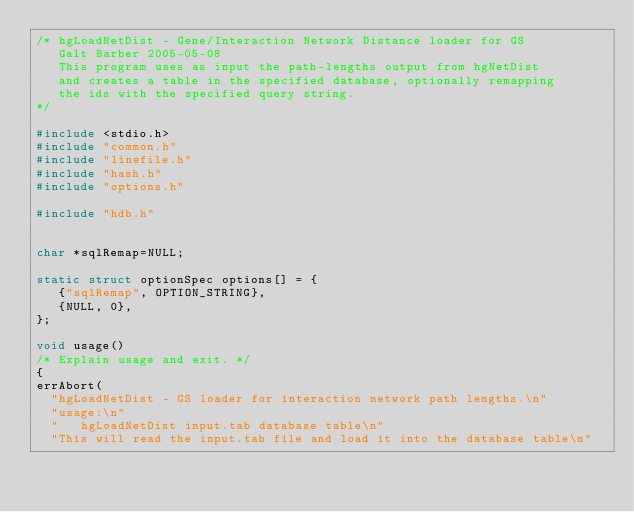Convert code to text. <code><loc_0><loc_0><loc_500><loc_500><_C_>/* hgLoadNetDist - Gene/Interaction Network Distance loader for GS 
   Galt Barber 2005-05-08
   This program uses as input the path-lengths output from hgNetDist
   and creates a table in the specified database, optionally remapping
   the ids with the specified query string.
*/

#include <stdio.h>
#include "common.h"
#include "linefile.h"
#include "hash.h"
#include "options.h"

#include "hdb.h"


char *sqlRemap=NULL;

static struct optionSpec options[] = {
   {"sqlRemap", OPTION_STRING},
   {NULL, 0},
};

void usage()
/* Explain usage and exit. */
{
errAbort(
  "hgLoadNetDist - GS loader for interaction network path lengths.\n"
  "usage:\n"
  "   hgLoadNetDist input.tab database table\n"
  "This will read the input.tab file and load it into the database table\n"</code> 